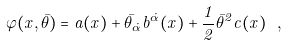<formula> <loc_0><loc_0><loc_500><loc_500>\varphi ( x , \bar { \theta } ) = a ( x ) + \bar { \theta } _ { \dot { \alpha } } b ^ { \dot { \alpha } } ( x ) + { \frac { 1 } { 2 } } \bar { \theta } ^ { 2 } c ( x ) \ ,</formula> 